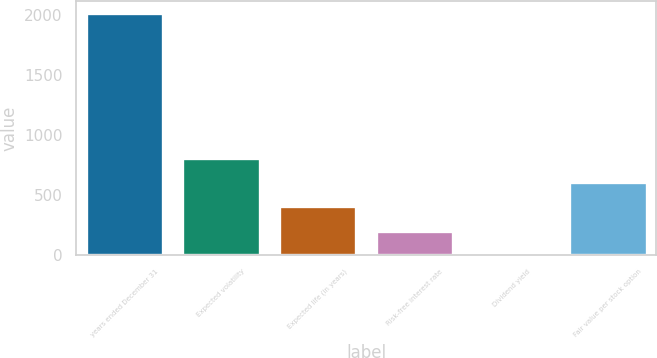Convert chart. <chart><loc_0><loc_0><loc_500><loc_500><bar_chart><fcel>years ended December 31<fcel>Expected volatility<fcel>Expected life (in years)<fcel>Risk-free interest rate<fcel>Dividend yield<fcel>Fair value per stock option<nl><fcel>2016<fcel>807.12<fcel>404.16<fcel>202.68<fcel>1.2<fcel>605.64<nl></chart> 